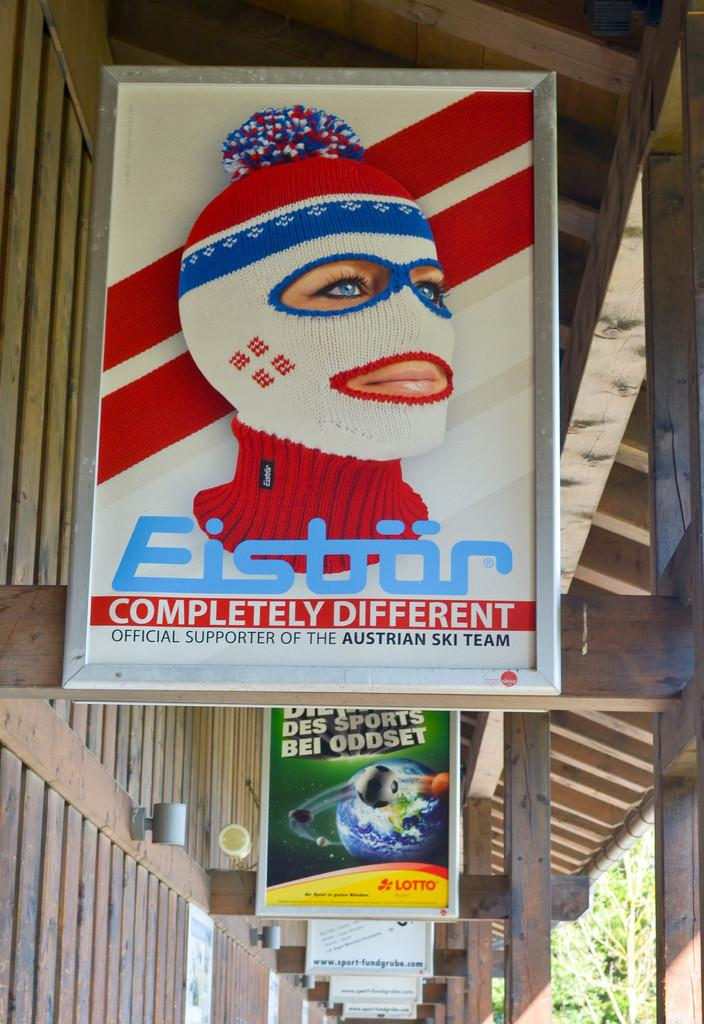<image>
Present a compact description of the photo's key features. The advertising poster shown advertises something completely different. 